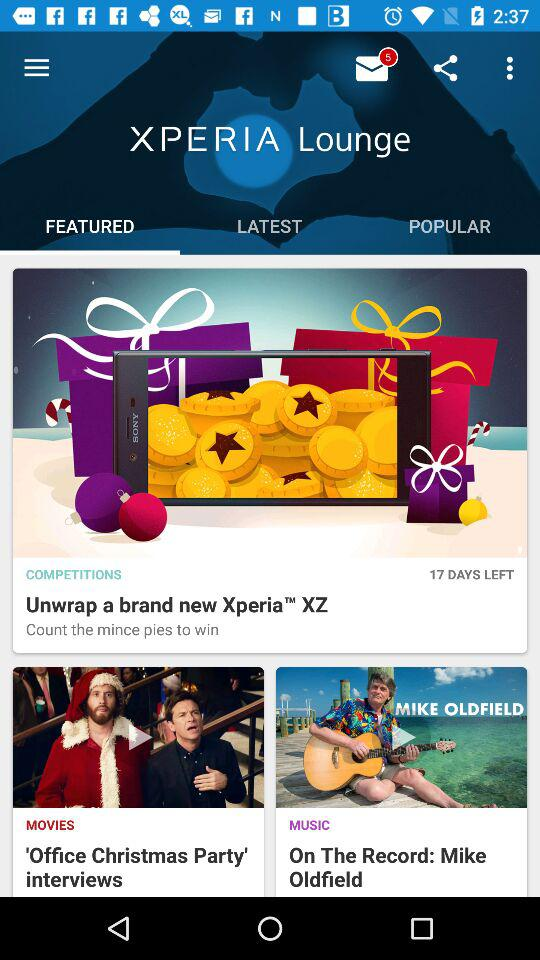Are there any unread messages? There are 5 unread messages. 